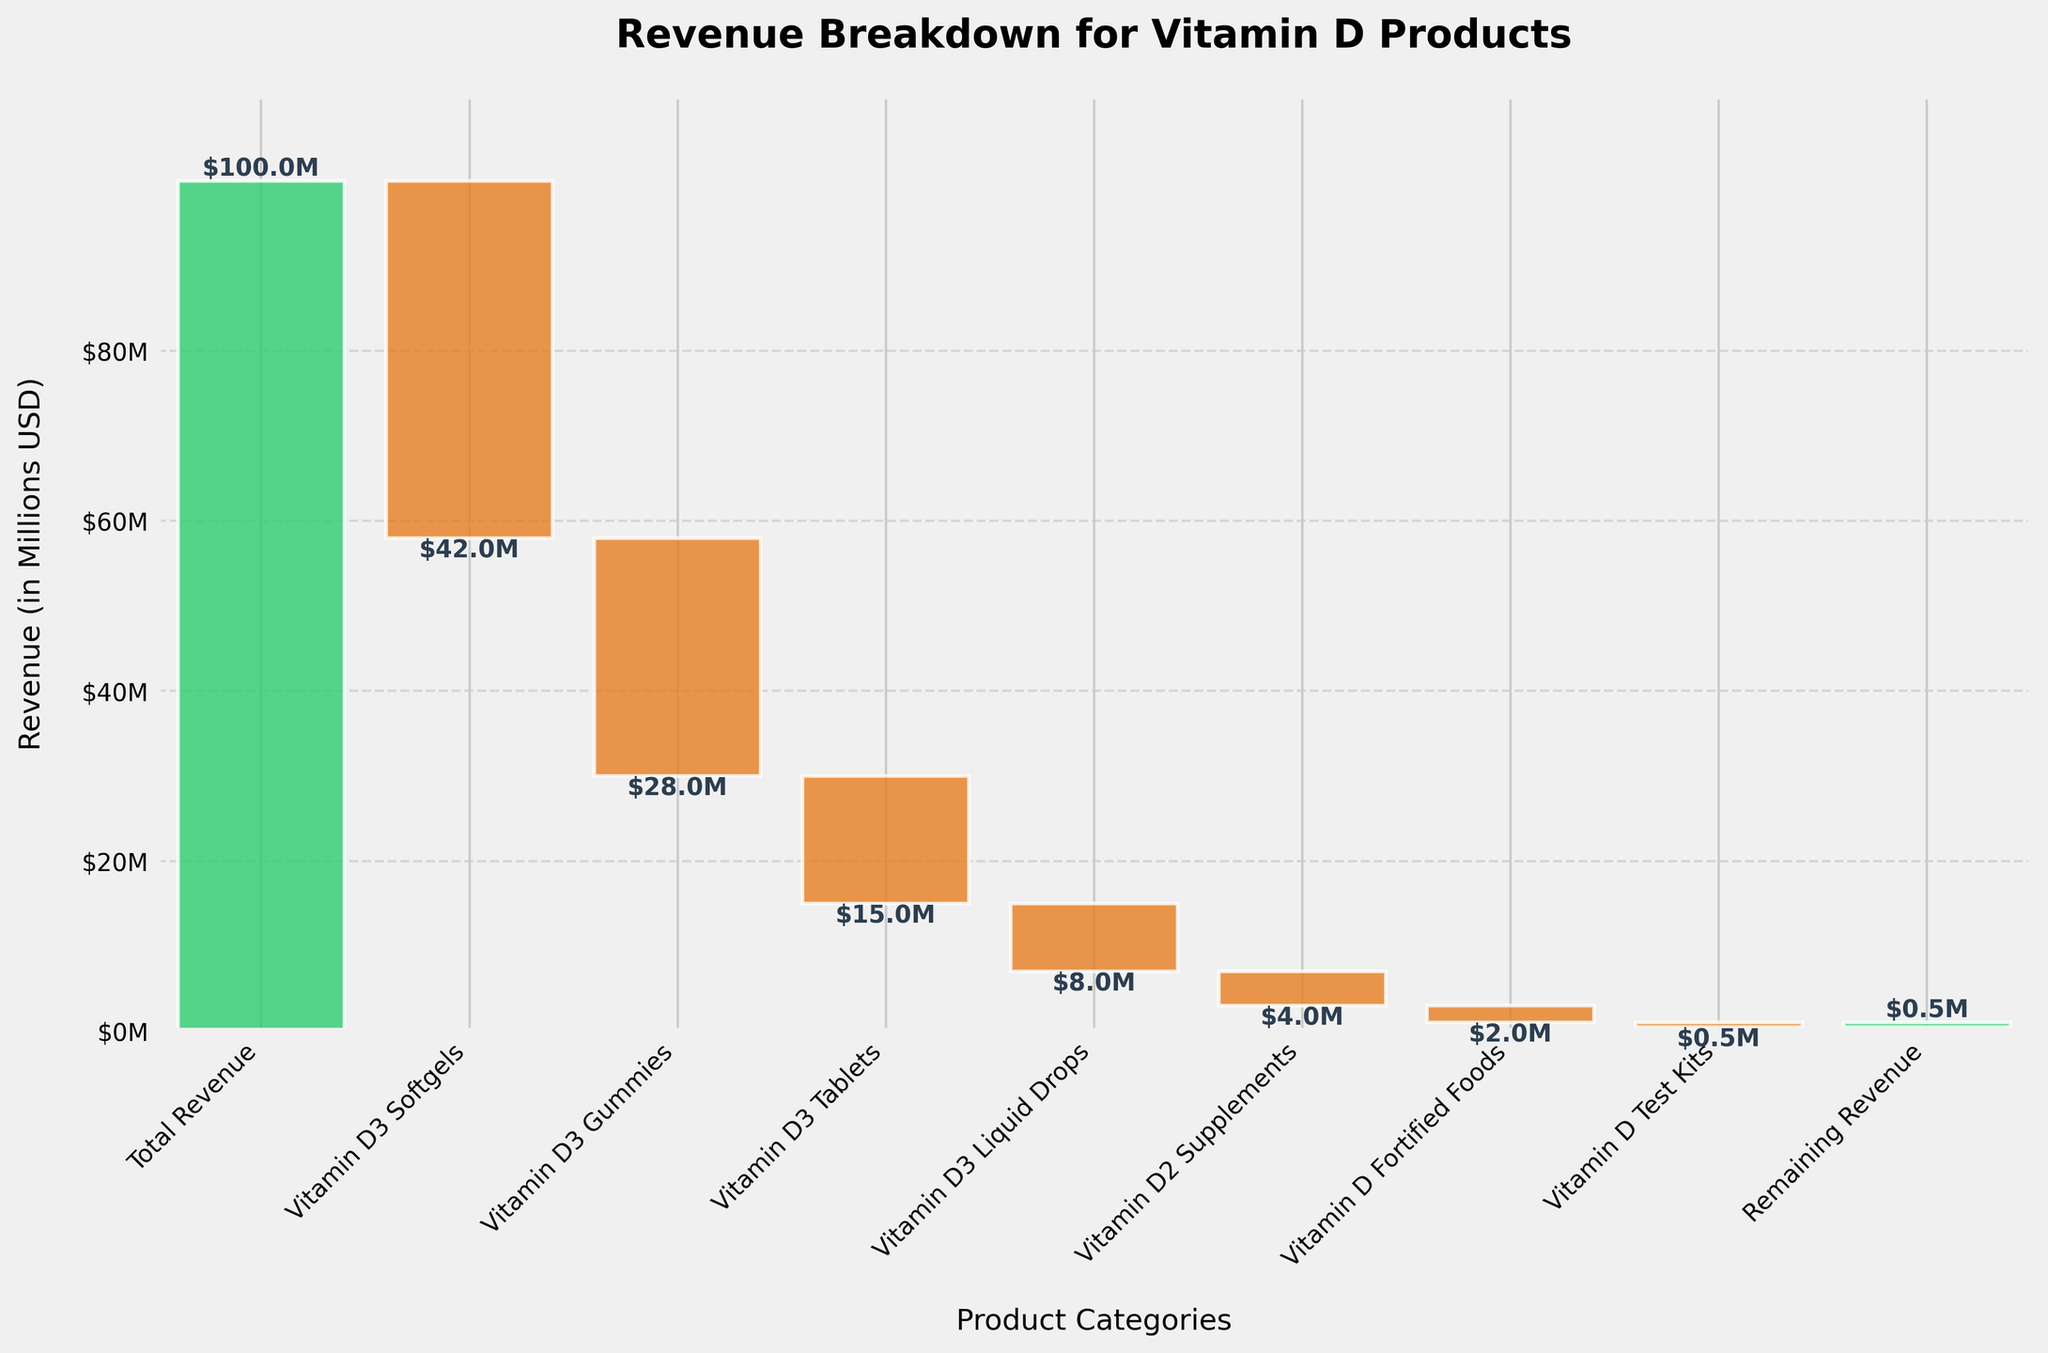What's the total revenue shown in the figure? The total revenue is given as the first segment in the waterfall chart, and it is labeled as "$100.0M" indicating $100 million.
Answer: $100 million How much revenue do Vitamin D3 Softgels contribute? The waterfall chart shows a negative segment for Vitamin D3 Softgels, and it is labeled as "$42.0M".
Answer: -$42 million By how much does the revenue drop after considering Vitamin D3 Gummies? The revenue drop due to Vitamin D3 Gummies is indicated in the chart segment which shows "$28.0M" in the negative direction.
Answer: $28 million What is the smallest revenue contribution category? By looking at the smallest segment which is labeled as "$0.5M", the Vitamin D Test Kits category has the smallest revenue contribution.
Answer: Vitamin D Test Kits What is the remaining revenue after all category contributions? The remaining revenue is marked as the last segment which shows "$0.5M" in positive.
Answer: $500K What is the total revenue loss contributed by Vitamin D3 products (Softgels, Gummies, Tablets, and Liquid Drops)? Add the negative values of Vitamin D3 Softgels (-$42M), Vitamin D3 Gummies (-$28M), Vitamin D3 Tablets (-$15M), and Vitamin D3 Liquid Drops (-$8M): -$42M + -$28M + -$15M + -$8M = -$93M.
Answer: -$93 million Which product category results in a higher revenue loss, Vitamin D2 Supplements or Vitamin D Fortified Foods? Compare the two respective segments: Vitamin D2 Supplements (-$4M) and Vitamin D Fortified Foods (-$2M). The Vitamin D2 Supplements result in a higher revenue loss.
Answer: Vitamin D2 Supplements What’s the total gross loss (excluding the remaining revenue)? Sum up all negative contributions except the remaining revenue: -$42M (Softgels) - $28M (Gummies) - $15M (Tablets) - $8M (Liquid Drops) - $4M (D2 Supplements) - $2M (Fortified Foods) - $0.5M (Test Kits): -$99.5M.
Answer: -$99.5 million How does the largest single-category revenue loss compare to the total negative contributions from Vitamin D2 Supplements, Vitamin D Fortified Foods, and Vitamin D Test Kits? The largest single-category revenue loss is from Vitamin D3 Softgels (-$42M). Sum the contributions of Vitamin D2 Supplements (-$4M), Vitamin D Fortified Foods (-$2M), and Vitamin D Test Kits (-$0.5M) = -$6.5M. $42M is significantly larger than $6.5M.
Answer: $42 million vs. $6.5 million What is the cumulative revenue after accounting for Vitamin D3 Tablets? Calculate the cumulative revenue by adding the first three segments: $100M (Total) - $42M (Softgels) - $28M (Gummies) - $15M (Tablets) = $15M.
Answer: $15 million 